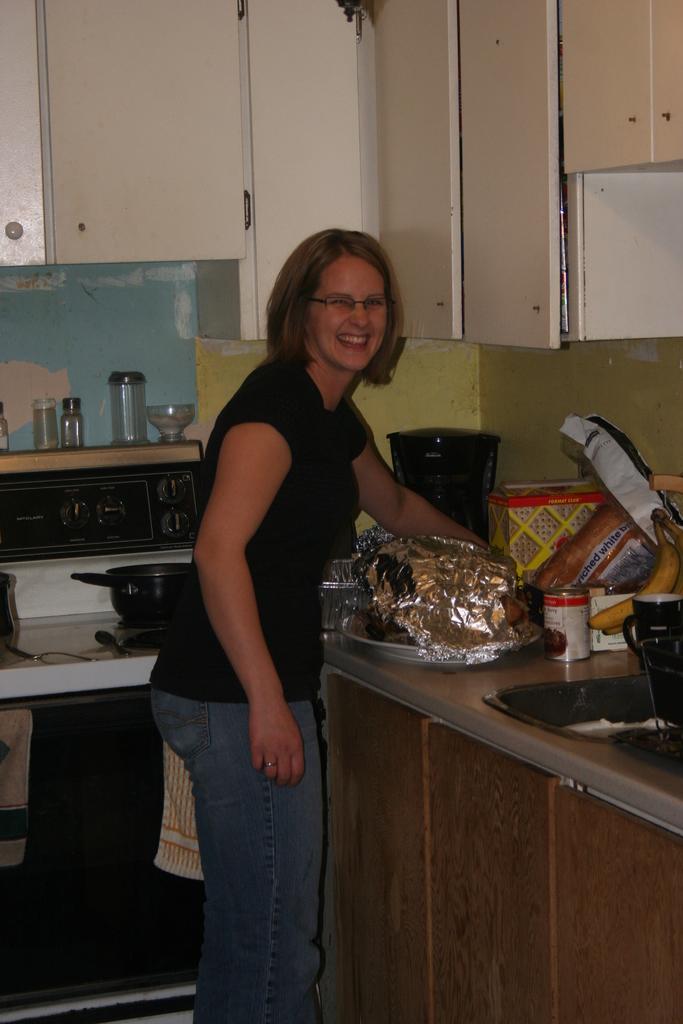What kind of bread does she have?
Offer a very short reply. Unanswerable. 